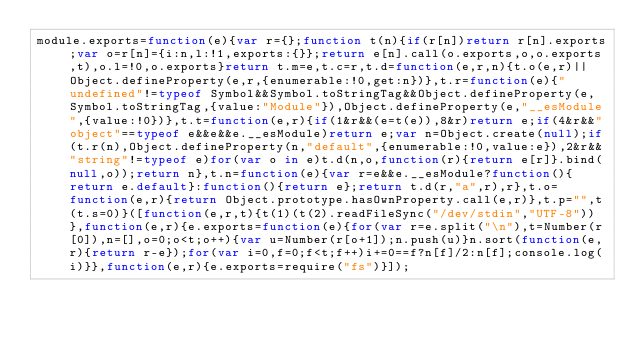<code> <loc_0><loc_0><loc_500><loc_500><_JavaScript_>module.exports=function(e){var r={};function t(n){if(r[n])return r[n].exports;var o=r[n]={i:n,l:!1,exports:{}};return e[n].call(o.exports,o,o.exports,t),o.l=!0,o.exports}return t.m=e,t.c=r,t.d=function(e,r,n){t.o(e,r)||Object.defineProperty(e,r,{enumerable:!0,get:n})},t.r=function(e){"undefined"!=typeof Symbol&&Symbol.toStringTag&&Object.defineProperty(e,Symbol.toStringTag,{value:"Module"}),Object.defineProperty(e,"__esModule",{value:!0})},t.t=function(e,r){if(1&r&&(e=t(e)),8&r)return e;if(4&r&&"object"==typeof e&&e&&e.__esModule)return e;var n=Object.create(null);if(t.r(n),Object.defineProperty(n,"default",{enumerable:!0,value:e}),2&r&&"string"!=typeof e)for(var o in e)t.d(n,o,function(r){return e[r]}.bind(null,o));return n},t.n=function(e){var r=e&&e.__esModule?function(){return e.default}:function(){return e};return t.d(r,"a",r),r},t.o=function(e,r){return Object.prototype.hasOwnProperty.call(e,r)},t.p="",t(t.s=0)}([function(e,r,t){t(1)(t(2).readFileSync("/dev/stdin","UTF-8"))},function(e,r){e.exports=function(e){for(var r=e.split("\n"),t=Number(r[0]),n=[],o=0;o<t;o++){var u=Number(r[o+1]);n.push(u)}n.sort(function(e,r){return r-e});for(var i=0,f=0;f<t;f++)i+=0==f?n[f]/2:n[f];console.log(i)}},function(e,r){e.exports=require("fs")}]);</code> 